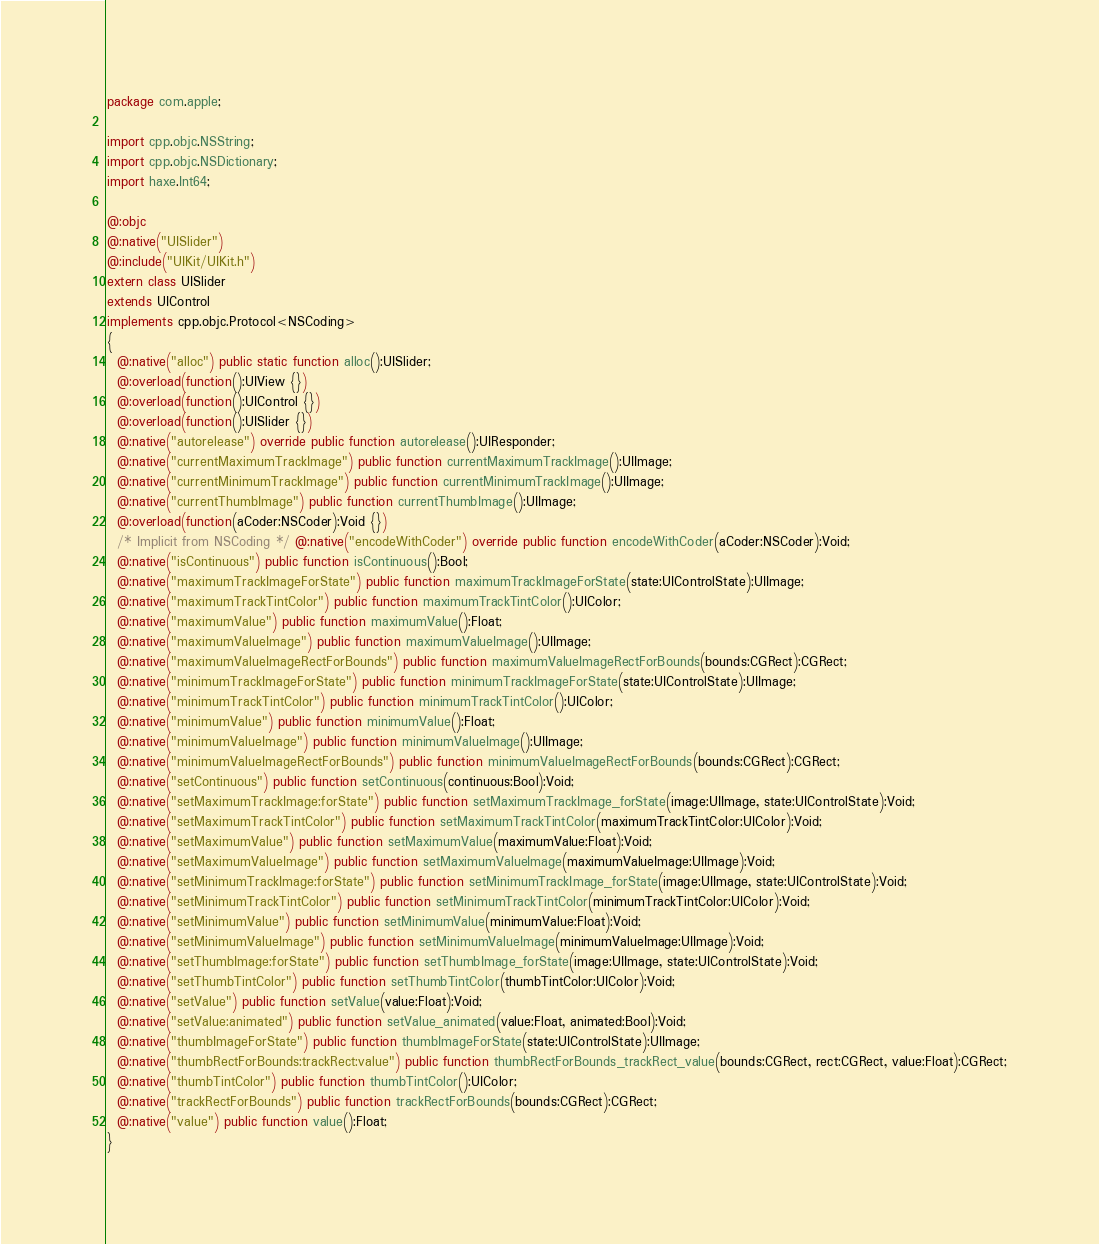Convert code to text. <code><loc_0><loc_0><loc_500><loc_500><_Haxe_>package com.apple;

import cpp.objc.NSString;
import cpp.objc.NSDictionary;
import haxe.Int64;

@:objc
@:native("UISlider")
@:include("UIKit/UIKit.h")
extern class UISlider
extends UIControl
implements cpp.objc.Protocol<NSCoding>
{
  @:native("alloc") public static function alloc():UISlider;
  @:overload(function():UIView {})
  @:overload(function():UIControl {})
  @:overload(function():UISlider {})
  @:native("autorelease") override public function autorelease():UIResponder;
  @:native("currentMaximumTrackImage") public function currentMaximumTrackImage():UIImage;
  @:native("currentMinimumTrackImage") public function currentMinimumTrackImage():UIImage;
  @:native("currentThumbImage") public function currentThumbImage():UIImage;
  @:overload(function(aCoder:NSCoder):Void {})
  /* Implicit from NSCoding */ @:native("encodeWithCoder") override public function encodeWithCoder(aCoder:NSCoder):Void;
  @:native("isContinuous") public function isContinuous():Bool;
  @:native("maximumTrackImageForState") public function maximumTrackImageForState(state:UIControlState):UIImage;
  @:native("maximumTrackTintColor") public function maximumTrackTintColor():UIColor;
  @:native("maximumValue") public function maximumValue():Float;
  @:native("maximumValueImage") public function maximumValueImage():UIImage;
  @:native("maximumValueImageRectForBounds") public function maximumValueImageRectForBounds(bounds:CGRect):CGRect;
  @:native("minimumTrackImageForState") public function minimumTrackImageForState(state:UIControlState):UIImage;
  @:native("minimumTrackTintColor") public function minimumTrackTintColor():UIColor;
  @:native("minimumValue") public function minimumValue():Float;
  @:native("minimumValueImage") public function minimumValueImage():UIImage;
  @:native("minimumValueImageRectForBounds") public function minimumValueImageRectForBounds(bounds:CGRect):CGRect;
  @:native("setContinuous") public function setContinuous(continuous:Bool):Void;
  @:native("setMaximumTrackImage:forState") public function setMaximumTrackImage_forState(image:UIImage, state:UIControlState):Void;
  @:native("setMaximumTrackTintColor") public function setMaximumTrackTintColor(maximumTrackTintColor:UIColor):Void;
  @:native("setMaximumValue") public function setMaximumValue(maximumValue:Float):Void;
  @:native("setMaximumValueImage") public function setMaximumValueImage(maximumValueImage:UIImage):Void;
  @:native("setMinimumTrackImage:forState") public function setMinimumTrackImage_forState(image:UIImage, state:UIControlState):Void;
  @:native("setMinimumTrackTintColor") public function setMinimumTrackTintColor(minimumTrackTintColor:UIColor):Void;
  @:native("setMinimumValue") public function setMinimumValue(minimumValue:Float):Void;
  @:native("setMinimumValueImage") public function setMinimumValueImage(minimumValueImage:UIImage):Void;
  @:native("setThumbImage:forState") public function setThumbImage_forState(image:UIImage, state:UIControlState):Void;
  @:native("setThumbTintColor") public function setThumbTintColor(thumbTintColor:UIColor):Void;
  @:native("setValue") public function setValue(value:Float):Void;
  @:native("setValue:animated") public function setValue_animated(value:Float, animated:Bool):Void;
  @:native("thumbImageForState") public function thumbImageForState(state:UIControlState):UIImage;
  @:native("thumbRectForBounds:trackRect:value") public function thumbRectForBounds_trackRect_value(bounds:CGRect, rect:CGRect, value:Float):CGRect;
  @:native("thumbTintColor") public function thumbTintColor():UIColor;
  @:native("trackRectForBounds") public function trackRectForBounds(bounds:CGRect):CGRect;
  @:native("value") public function value():Float;
}
</code> 